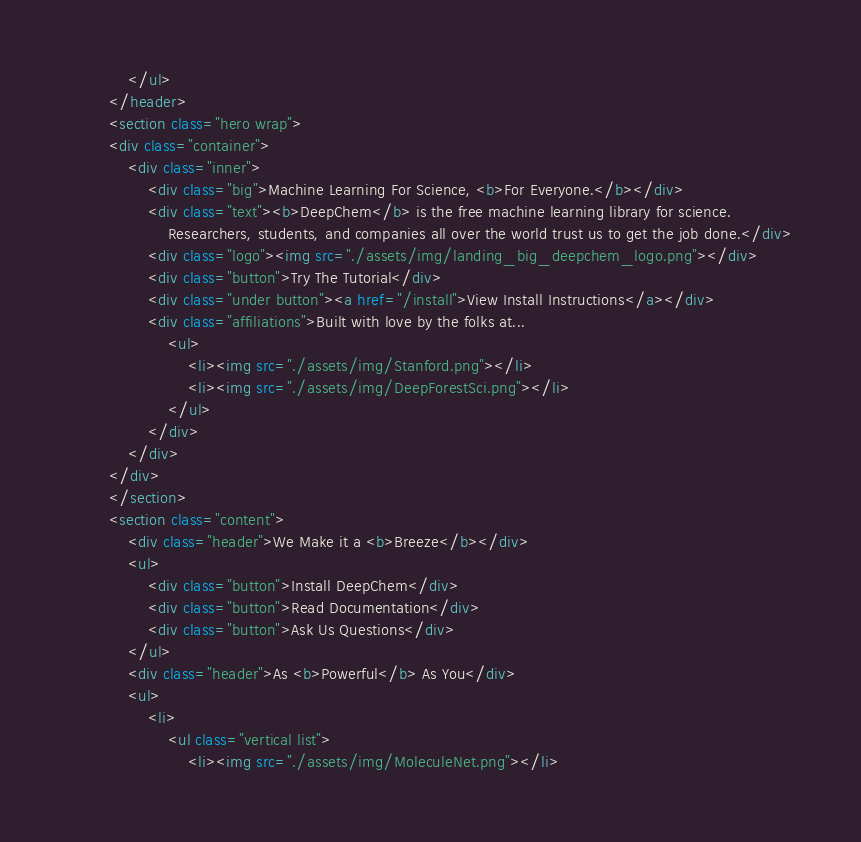<code> <loc_0><loc_0><loc_500><loc_500><_HTML_>            </ul>
        </header>
        <section class="hero wrap">
        <div class="container">
            <div class="inner">
                <div class="big">Machine Learning For Science, <b>For Everyone.</b></div>
                <div class="text"><b>DeepChem</b> is the free machine learning library for science.
                    Researchers, students, and companies all over the world trust us to get the job done.</div>
                <div class="logo"><img src="./assets/img/landing_big_deepchem_logo.png"></div>
                <div class="button">Try The Tutorial</div>
                <div class="under button"><a href="/install">View Install Instructions</a></div>
                <div class="affiliations">Built with love by the folks at...
                    <ul>
                        <li><img src="./assets/img/Stanford.png"></li>
                        <li><img src="./assets/img/DeepForestSci.png"></li>
                    </ul>
                </div>
            </div>
        </div>
        </section>
        <section class="content">
            <div class="header">We Make it a <b>Breeze</b></div>
            <ul>
                <div class="button">Install DeepChem</div>
                <div class="button">Read Documentation</div>
                <div class="button">Ask Us Questions</div>
            </ul>
            <div class="header">As <b>Powerful</b> As You</div>
            <ul>
                <li>
                    <ul class="vertical list">
                        <li><img src="./assets/img/MoleculeNet.png"></li></code> 